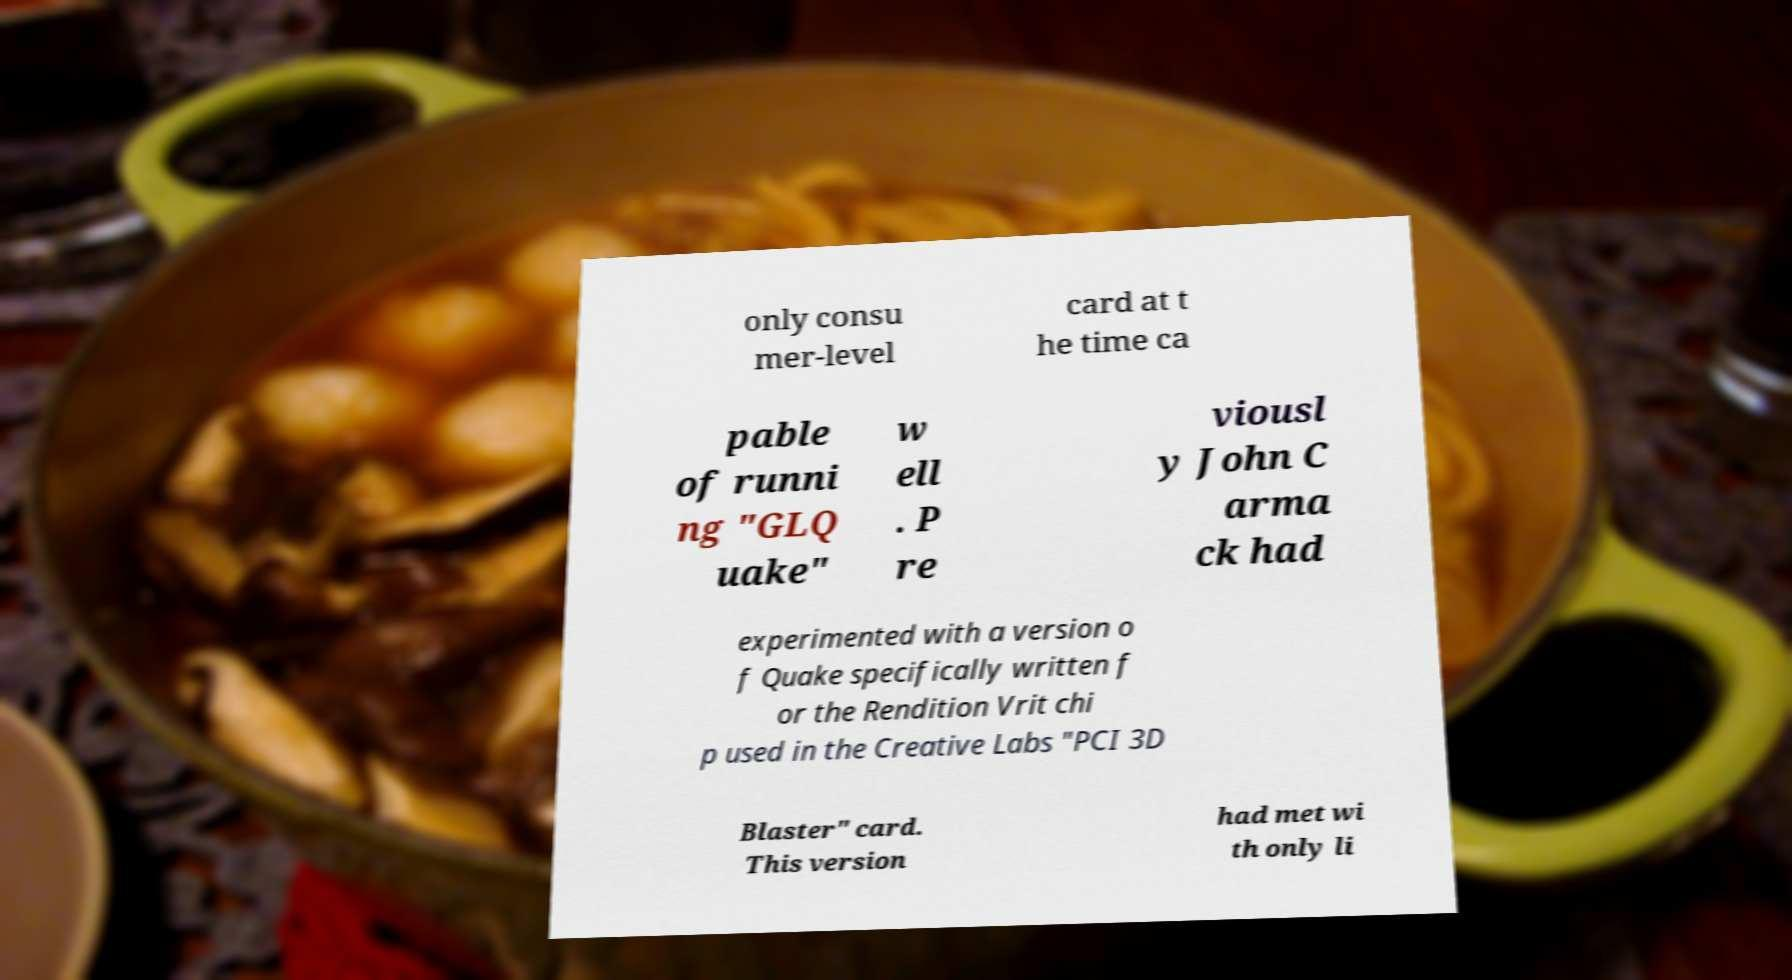There's text embedded in this image that I need extracted. Can you transcribe it verbatim? only consu mer-level card at t he time ca pable of runni ng "GLQ uake" w ell . P re viousl y John C arma ck had experimented with a version o f Quake specifically written f or the Rendition Vrit chi p used in the Creative Labs "PCI 3D Blaster" card. This version had met wi th only li 